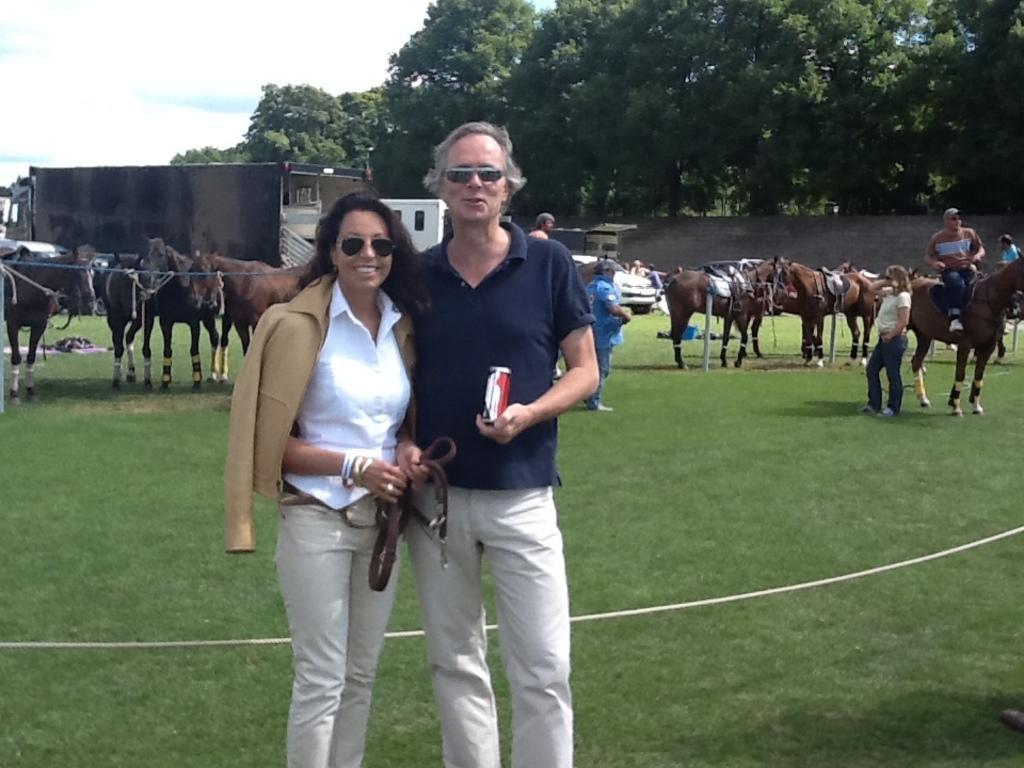Please provide a concise description of this image. This picture is taken in a grounds. In the center there are two persons, one woman and one man. The woman is wearing white t shirt, cream trousers, cream jacket, goggles and holding a belt, there is a man besides her and he is wearing a blue t shirt, cream trousers, goggles and holding a can. There is a green glass on the ground. To the right corner there is a horse and a person sitting on it and a woman besides that horse. In the background there is a white truck, building, some trees and blue sky. In the left corner there are some horses. 